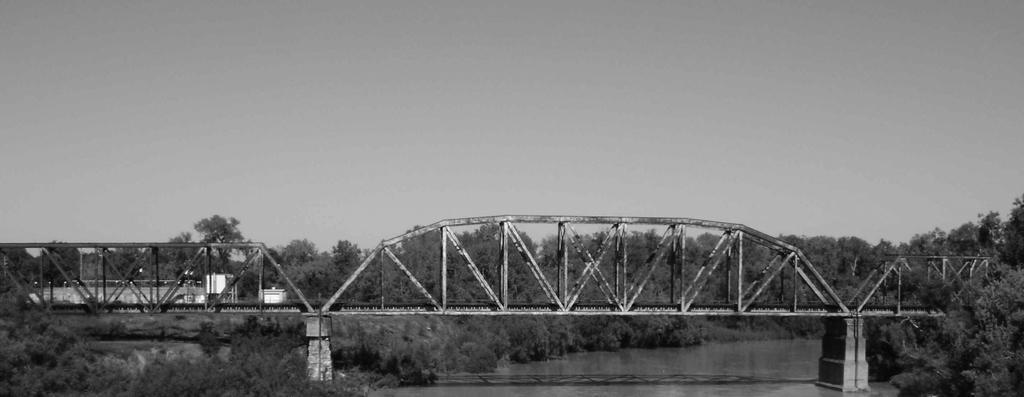Please provide a concise description of this image. In this image we can see a bridge, there are some trees, metal rods,buildings, poles, lights and water, in the background we can see the sky. 